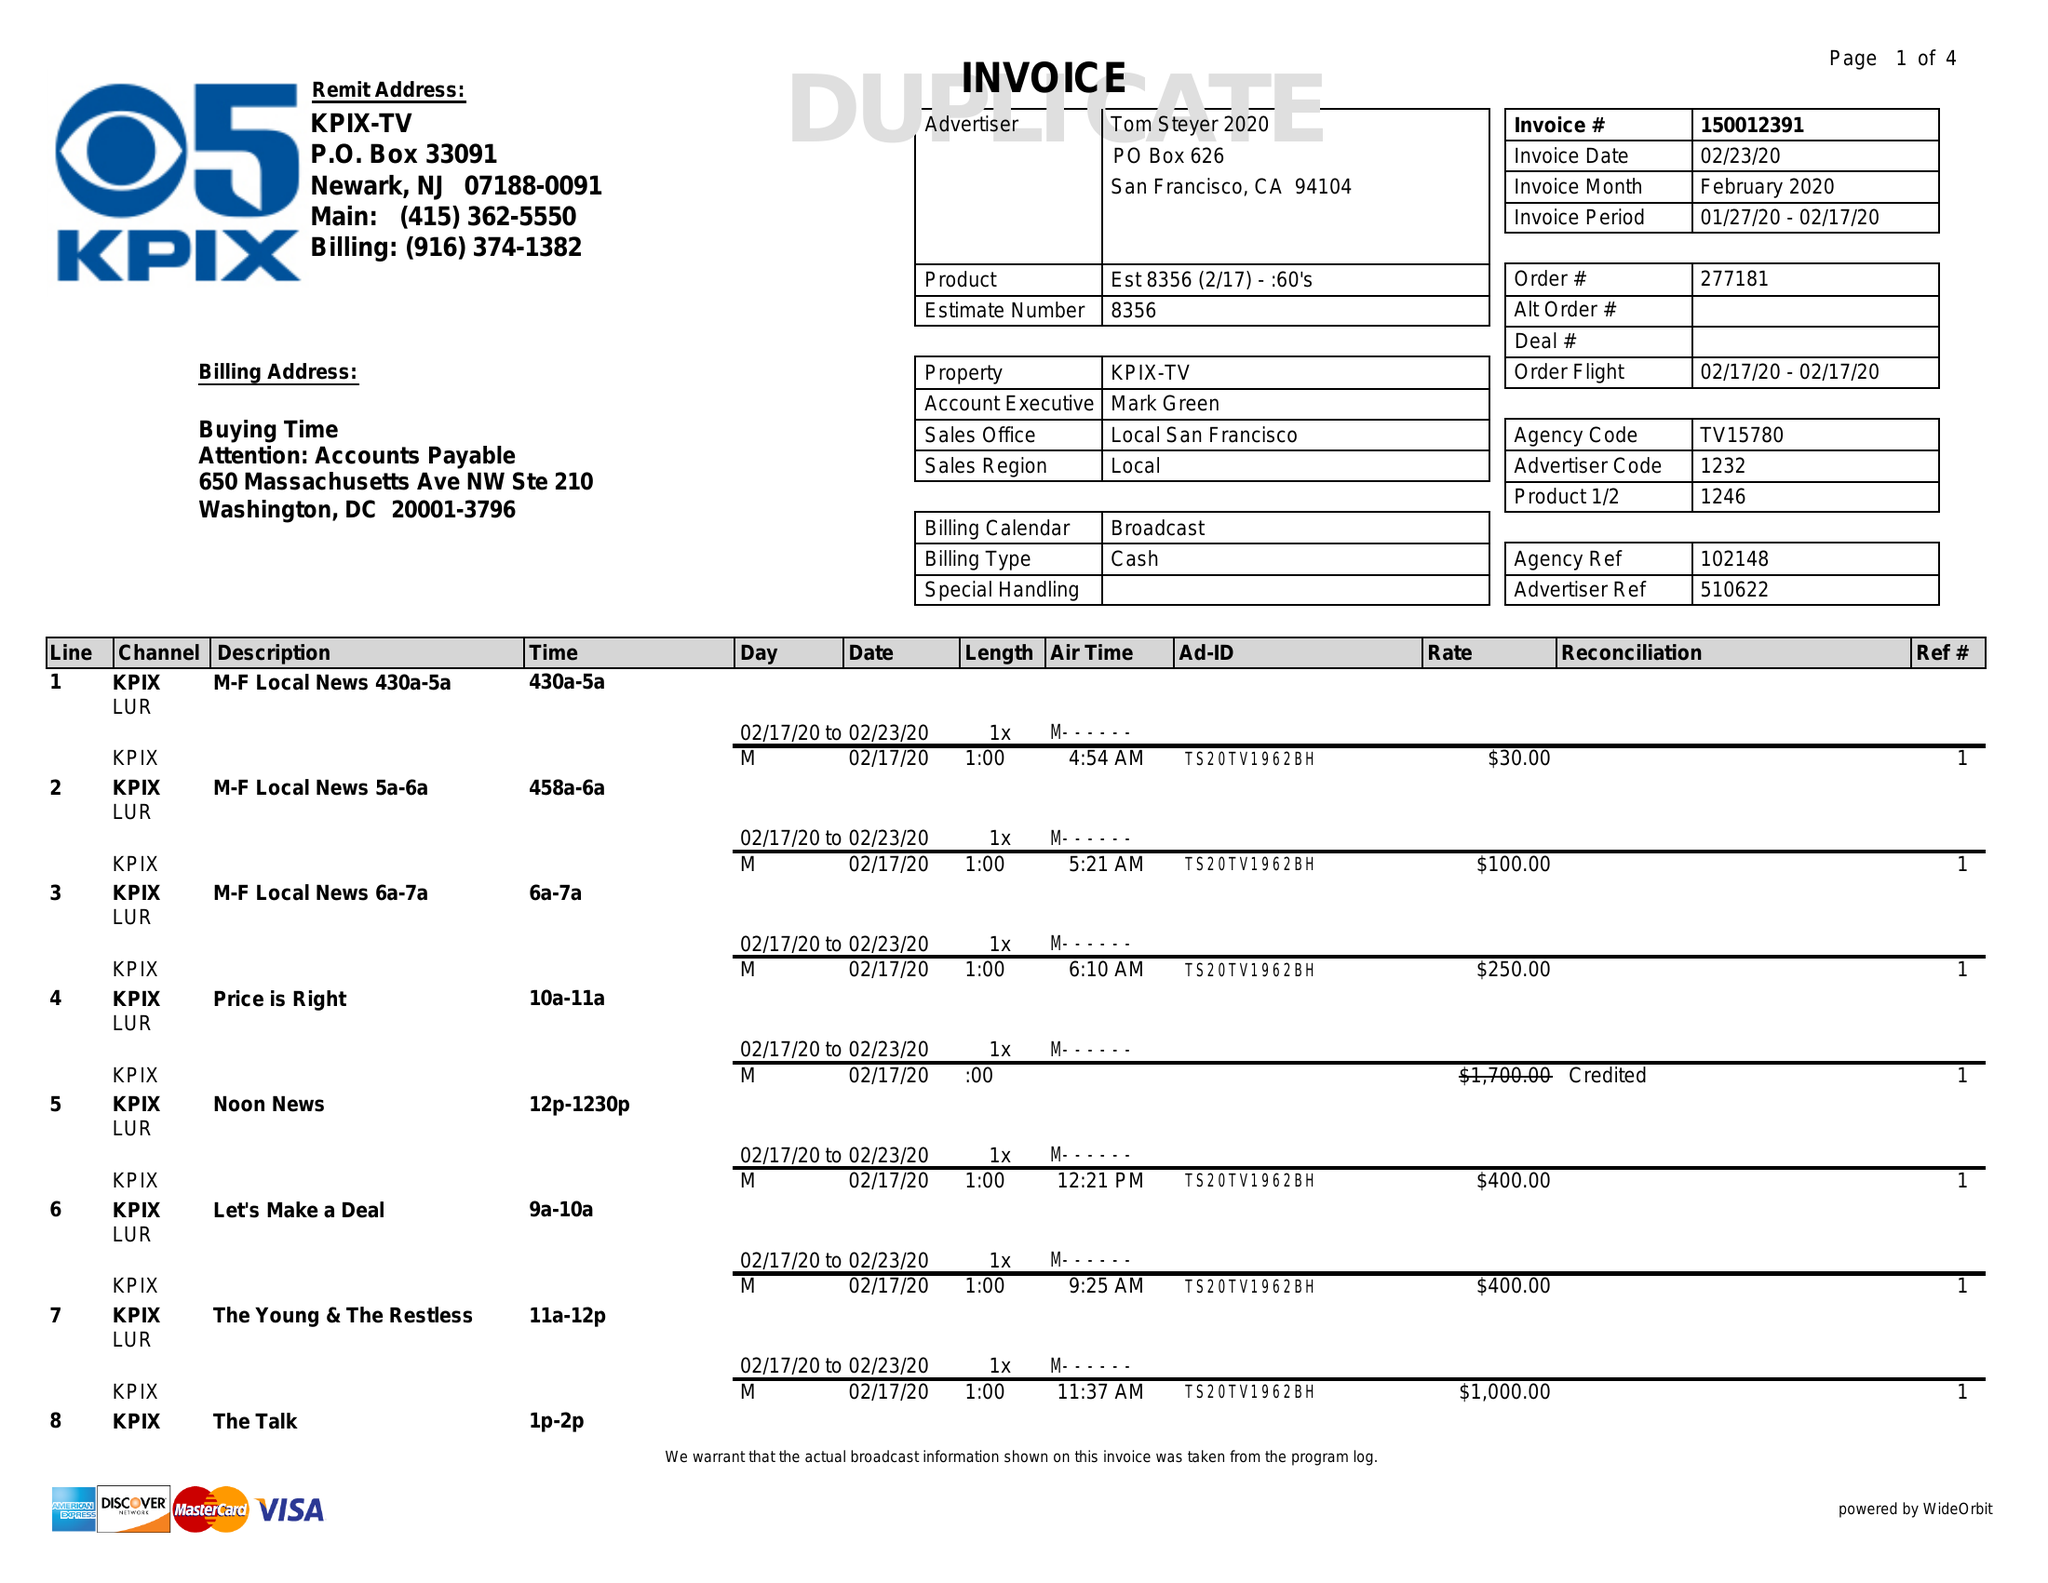What is the value for the flight_to?
Answer the question using a single word or phrase. 02/17/20 